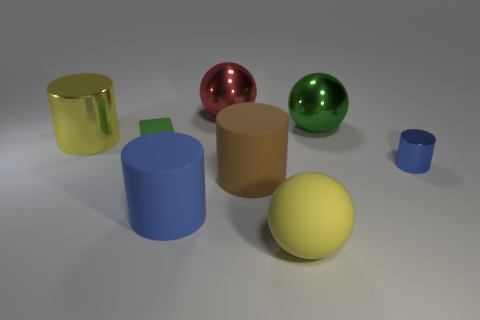There is a big cylinder behind the green object to the left of the red ball; are there any big metallic things that are behind it?
Keep it short and to the point. Yes. Is the shape of the yellow object that is in front of the small blue metallic cylinder the same as  the red metal thing?
Make the answer very short. Yes. The blue object to the left of the large yellow thing that is right of the big red metal thing is what shape?
Ensure brevity in your answer.  Cylinder. There is a blue object that is left of the shiny thing in front of the metallic cylinder behind the blue metallic cylinder; what is its size?
Provide a succinct answer. Large. What is the color of the other metallic thing that is the same shape as the big red object?
Offer a very short reply. Green. Is the green rubber thing the same size as the blue metallic cylinder?
Provide a short and direct response. Yes. There is a green object behind the large yellow shiny thing; what is its material?
Make the answer very short. Metal. What number of other things are the same shape as the big blue object?
Provide a short and direct response. 3. Is the shape of the red thing the same as the small matte thing?
Offer a terse response. No. Are there any large blue rubber cylinders in front of the large brown rubber object?
Offer a terse response. Yes. 